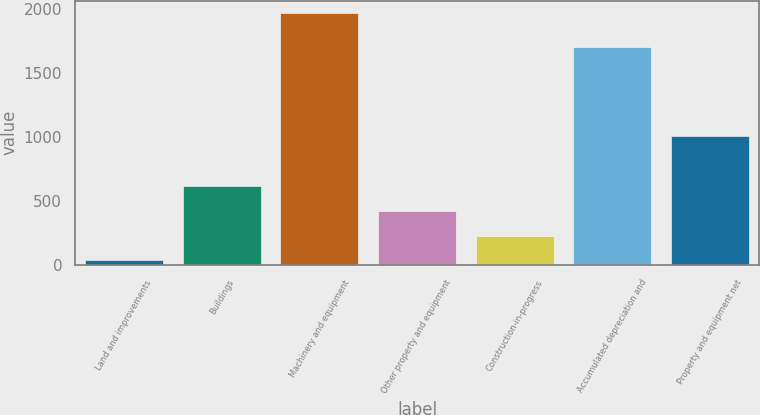<chart> <loc_0><loc_0><loc_500><loc_500><bar_chart><fcel>Land and improvements<fcel>Buildings<fcel>Machinery and equipment<fcel>Other property and equipment<fcel>Construction-in-progress<fcel>Accumulated depreciation and<fcel>Property and equipment net<nl><fcel>35.5<fcel>615.73<fcel>1969.6<fcel>422.32<fcel>228.91<fcel>1704.9<fcel>1008.6<nl></chart> 